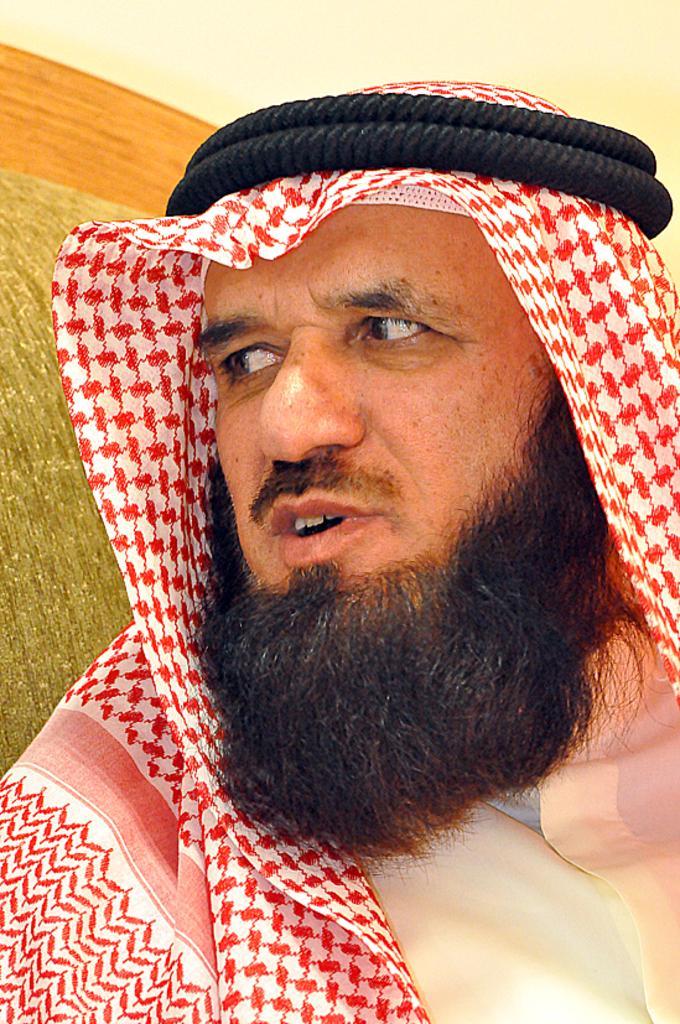Could you give a brief overview of what you see in this image? In the center of the image there is a person. In the background we can see wall. 